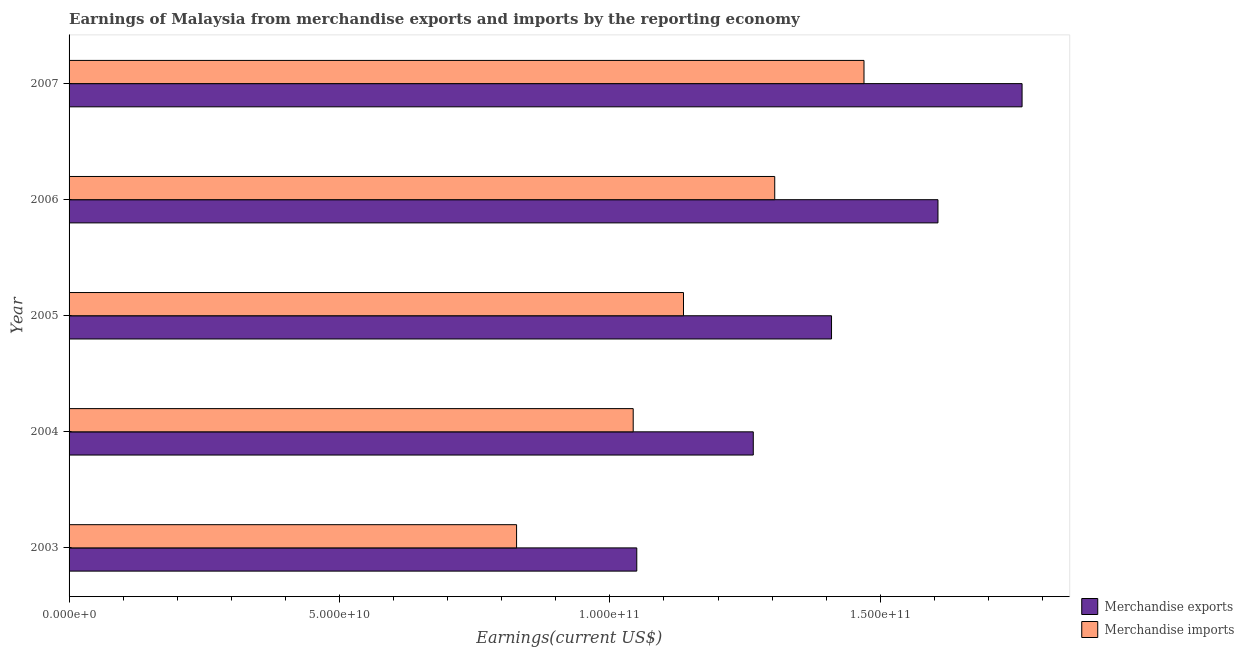How many groups of bars are there?
Offer a very short reply. 5. Are the number of bars per tick equal to the number of legend labels?
Make the answer very short. Yes. Are the number of bars on each tick of the Y-axis equal?
Your answer should be compact. Yes. How many bars are there on the 5th tick from the bottom?
Offer a very short reply. 2. What is the label of the 3rd group of bars from the top?
Make the answer very short. 2005. What is the earnings from merchandise imports in 2004?
Your answer should be very brief. 1.04e+11. Across all years, what is the maximum earnings from merchandise imports?
Make the answer very short. 1.47e+11. Across all years, what is the minimum earnings from merchandise imports?
Make the answer very short. 8.27e+1. In which year was the earnings from merchandise imports maximum?
Your response must be concise. 2007. What is the total earnings from merchandise exports in the graph?
Your answer should be compact. 7.09e+11. What is the difference between the earnings from merchandise imports in 2003 and that in 2004?
Give a very brief answer. -2.16e+1. What is the difference between the earnings from merchandise imports in 2006 and the earnings from merchandise exports in 2003?
Your response must be concise. 2.55e+1. What is the average earnings from merchandise exports per year?
Give a very brief answer. 1.42e+11. In the year 2004, what is the difference between the earnings from merchandise exports and earnings from merchandise imports?
Ensure brevity in your answer.  2.22e+1. In how many years, is the earnings from merchandise exports greater than 130000000000 US$?
Your answer should be very brief. 3. What is the ratio of the earnings from merchandise imports in 2005 to that in 2006?
Keep it short and to the point. 0.87. Is the earnings from merchandise imports in 2004 less than that in 2007?
Your answer should be very brief. Yes. What is the difference between the highest and the second highest earnings from merchandise exports?
Offer a terse response. 1.56e+1. What is the difference between the highest and the lowest earnings from merchandise imports?
Make the answer very short. 6.42e+1. What does the 2nd bar from the top in 2007 represents?
Your response must be concise. Merchandise exports. What does the 2nd bar from the bottom in 2007 represents?
Offer a very short reply. Merchandise imports. How many bars are there?
Provide a succinct answer. 10. Are all the bars in the graph horizontal?
Your response must be concise. Yes. How many years are there in the graph?
Provide a short and direct response. 5. Does the graph contain any zero values?
Your response must be concise. No. How are the legend labels stacked?
Make the answer very short. Vertical. What is the title of the graph?
Offer a terse response. Earnings of Malaysia from merchandise exports and imports by the reporting economy. What is the label or title of the X-axis?
Provide a short and direct response. Earnings(current US$). What is the Earnings(current US$) of Merchandise exports in 2003?
Your answer should be very brief. 1.05e+11. What is the Earnings(current US$) in Merchandise imports in 2003?
Keep it short and to the point. 8.27e+1. What is the Earnings(current US$) in Merchandise exports in 2004?
Your response must be concise. 1.27e+11. What is the Earnings(current US$) in Merchandise imports in 2004?
Make the answer very short. 1.04e+11. What is the Earnings(current US$) of Merchandise exports in 2005?
Your answer should be very brief. 1.41e+11. What is the Earnings(current US$) of Merchandise imports in 2005?
Offer a terse response. 1.14e+11. What is the Earnings(current US$) in Merchandise exports in 2006?
Your response must be concise. 1.61e+11. What is the Earnings(current US$) in Merchandise imports in 2006?
Provide a succinct answer. 1.30e+11. What is the Earnings(current US$) in Merchandise exports in 2007?
Give a very brief answer. 1.76e+11. What is the Earnings(current US$) of Merchandise imports in 2007?
Offer a very short reply. 1.47e+11. Across all years, what is the maximum Earnings(current US$) of Merchandise exports?
Your answer should be compact. 1.76e+11. Across all years, what is the maximum Earnings(current US$) in Merchandise imports?
Your answer should be compact. 1.47e+11. Across all years, what is the minimum Earnings(current US$) of Merchandise exports?
Provide a succinct answer. 1.05e+11. Across all years, what is the minimum Earnings(current US$) of Merchandise imports?
Make the answer very short. 8.27e+1. What is the total Earnings(current US$) in Merchandise exports in the graph?
Your answer should be very brief. 7.09e+11. What is the total Earnings(current US$) in Merchandise imports in the graph?
Offer a very short reply. 5.78e+11. What is the difference between the Earnings(current US$) in Merchandise exports in 2003 and that in 2004?
Ensure brevity in your answer.  -2.15e+1. What is the difference between the Earnings(current US$) in Merchandise imports in 2003 and that in 2004?
Offer a very short reply. -2.16e+1. What is the difference between the Earnings(current US$) in Merchandise exports in 2003 and that in 2005?
Your answer should be compact. -3.60e+1. What is the difference between the Earnings(current US$) of Merchandise imports in 2003 and that in 2005?
Ensure brevity in your answer.  -3.09e+1. What is the difference between the Earnings(current US$) in Merchandise exports in 2003 and that in 2006?
Your response must be concise. -5.57e+1. What is the difference between the Earnings(current US$) of Merchandise imports in 2003 and that in 2006?
Offer a terse response. -4.77e+1. What is the difference between the Earnings(current US$) of Merchandise exports in 2003 and that in 2007?
Keep it short and to the point. -7.12e+1. What is the difference between the Earnings(current US$) of Merchandise imports in 2003 and that in 2007?
Your response must be concise. -6.42e+1. What is the difference between the Earnings(current US$) in Merchandise exports in 2004 and that in 2005?
Offer a very short reply. -1.45e+1. What is the difference between the Earnings(current US$) in Merchandise imports in 2004 and that in 2005?
Your answer should be very brief. -9.30e+09. What is the difference between the Earnings(current US$) in Merchandise exports in 2004 and that in 2006?
Your answer should be compact. -3.41e+1. What is the difference between the Earnings(current US$) in Merchandise imports in 2004 and that in 2006?
Provide a succinct answer. -2.62e+1. What is the difference between the Earnings(current US$) of Merchandise exports in 2004 and that in 2007?
Make the answer very short. -4.97e+1. What is the difference between the Earnings(current US$) of Merchandise imports in 2004 and that in 2007?
Offer a terse response. -4.27e+1. What is the difference between the Earnings(current US$) in Merchandise exports in 2005 and that in 2006?
Keep it short and to the point. -1.97e+1. What is the difference between the Earnings(current US$) of Merchandise imports in 2005 and that in 2006?
Provide a succinct answer. -1.69e+1. What is the difference between the Earnings(current US$) in Merchandise exports in 2005 and that in 2007?
Provide a short and direct response. -3.52e+1. What is the difference between the Earnings(current US$) in Merchandise imports in 2005 and that in 2007?
Offer a very short reply. -3.34e+1. What is the difference between the Earnings(current US$) in Merchandise exports in 2006 and that in 2007?
Your response must be concise. -1.56e+1. What is the difference between the Earnings(current US$) in Merchandise imports in 2006 and that in 2007?
Make the answer very short. -1.65e+1. What is the difference between the Earnings(current US$) of Merchandise exports in 2003 and the Earnings(current US$) of Merchandise imports in 2004?
Offer a terse response. 6.62e+08. What is the difference between the Earnings(current US$) of Merchandise exports in 2003 and the Earnings(current US$) of Merchandise imports in 2005?
Your response must be concise. -8.64e+09. What is the difference between the Earnings(current US$) in Merchandise exports in 2003 and the Earnings(current US$) in Merchandise imports in 2006?
Your answer should be very brief. -2.55e+1. What is the difference between the Earnings(current US$) in Merchandise exports in 2003 and the Earnings(current US$) in Merchandise imports in 2007?
Your answer should be very brief. -4.20e+1. What is the difference between the Earnings(current US$) in Merchandise exports in 2004 and the Earnings(current US$) in Merchandise imports in 2005?
Your answer should be compact. 1.29e+1. What is the difference between the Earnings(current US$) in Merchandise exports in 2004 and the Earnings(current US$) in Merchandise imports in 2006?
Your answer should be very brief. -3.97e+09. What is the difference between the Earnings(current US$) of Merchandise exports in 2004 and the Earnings(current US$) of Merchandise imports in 2007?
Keep it short and to the point. -2.05e+1. What is the difference between the Earnings(current US$) of Merchandise exports in 2005 and the Earnings(current US$) of Merchandise imports in 2006?
Ensure brevity in your answer.  1.05e+1. What is the difference between the Earnings(current US$) of Merchandise exports in 2005 and the Earnings(current US$) of Merchandise imports in 2007?
Your response must be concise. -6.00e+09. What is the difference between the Earnings(current US$) of Merchandise exports in 2006 and the Earnings(current US$) of Merchandise imports in 2007?
Give a very brief answer. 1.37e+1. What is the average Earnings(current US$) of Merchandise exports per year?
Your response must be concise. 1.42e+11. What is the average Earnings(current US$) of Merchandise imports per year?
Keep it short and to the point. 1.16e+11. In the year 2003, what is the difference between the Earnings(current US$) of Merchandise exports and Earnings(current US$) of Merchandise imports?
Offer a very short reply. 2.22e+1. In the year 2004, what is the difference between the Earnings(current US$) of Merchandise exports and Earnings(current US$) of Merchandise imports?
Offer a terse response. 2.22e+1. In the year 2005, what is the difference between the Earnings(current US$) of Merchandise exports and Earnings(current US$) of Merchandise imports?
Your answer should be very brief. 2.74e+1. In the year 2006, what is the difference between the Earnings(current US$) in Merchandise exports and Earnings(current US$) in Merchandise imports?
Give a very brief answer. 3.02e+1. In the year 2007, what is the difference between the Earnings(current US$) in Merchandise exports and Earnings(current US$) in Merchandise imports?
Provide a short and direct response. 2.92e+1. What is the ratio of the Earnings(current US$) in Merchandise exports in 2003 to that in 2004?
Offer a terse response. 0.83. What is the ratio of the Earnings(current US$) of Merchandise imports in 2003 to that in 2004?
Ensure brevity in your answer.  0.79. What is the ratio of the Earnings(current US$) in Merchandise exports in 2003 to that in 2005?
Your answer should be very brief. 0.74. What is the ratio of the Earnings(current US$) in Merchandise imports in 2003 to that in 2005?
Keep it short and to the point. 0.73. What is the ratio of the Earnings(current US$) in Merchandise exports in 2003 to that in 2006?
Offer a very short reply. 0.65. What is the ratio of the Earnings(current US$) in Merchandise imports in 2003 to that in 2006?
Provide a short and direct response. 0.63. What is the ratio of the Earnings(current US$) in Merchandise exports in 2003 to that in 2007?
Your answer should be very brief. 0.6. What is the ratio of the Earnings(current US$) of Merchandise imports in 2003 to that in 2007?
Give a very brief answer. 0.56. What is the ratio of the Earnings(current US$) of Merchandise exports in 2004 to that in 2005?
Provide a succinct answer. 0.9. What is the ratio of the Earnings(current US$) in Merchandise imports in 2004 to that in 2005?
Give a very brief answer. 0.92. What is the ratio of the Earnings(current US$) in Merchandise exports in 2004 to that in 2006?
Ensure brevity in your answer.  0.79. What is the ratio of the Earnings(current US$) in Merchandise imports in 2004 to that in 2006?
Offer a very short reply. 0.8. What is the ratio of the Earnings(current US$) of Merchandise exports in 2004 to that in 2007?
Make the answer very short. 0.72. What is the ratio of the Earnings(current US$) of Merchandise imports in 2004 to that in 2007?
Your answer should be very brief. 0.71. What is the ratio of the Earnings(current US$) of Merchandise exports in 2005 to that in 2006?
Your response must be concise. 0.88. What is the ratio of the Earnings(current US$) in Merchandise imports in 2005 to that in 2006?
Provide a short and direct response. 0.87. What is the ratio of the Earnings(current US$) of Merchandise exports in 2005 to that in 2007?
Make the answer very short. 0.8. What is the ratio of the Earnings(current US$) of Merchandise imports in 2005 to that in 2007?
Keep it short and to the point. 0.77. What is the ratio of the Earnings(current US$) in Merchandise exports in 2006 to that in 2007?
Make the answer very short. 0.91. What is the ratio of the Earnings(current US$) in Merchandise imports in 2006 to that in 2007?
Your answer should be very brief. 0.89. What is the difference between the highest and the second highest Earnings(current US$) in Merchandise exports?
Your answer should be very brief. 1.56e+1. What is the difference between the highest and the second highest Earnings(current US$) of Merchandise imports?
Offer a terse response. 1.65e+1. What is the difference between the highest and the lowest Earnings(current US$) of Merchandise exports?
Give a very brief answer. 7.12e+1. What is the difference between the highest and the lowest Earnings(current US$) in Merchandise imports?
Provide a succinct answer. 6.42e+1. 